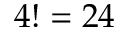<formula> <loc_0><loc_0><loc_500><loc_500>4 ! = 2 4</formula> 